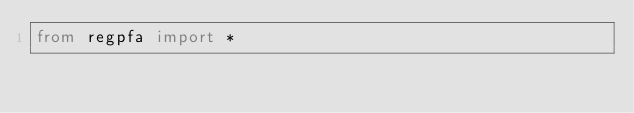Convert code to text. <code><loc_0><loc_0><loc_500><loc_500><_Python_>from regpfa import *</code> 